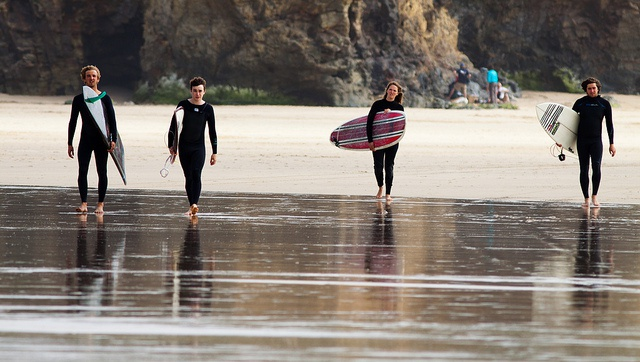Describe the objects in this image and their specific colors. I can see people in black, lightgray, and maroon tones, people in black, lightgray, brown, and gray tones, people in black, gray, brown, and maroon tones, surfboard in black, gray, purple, maroon, and darkgray tones, and people in black, brown, maroon, and gray tones in this image. 